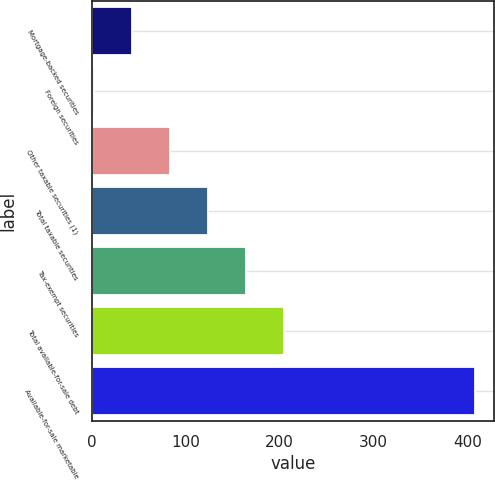Convert chart to OTSL. <chart><loc_0><loc_0><loc_500><loc_500><bar_chart><fcel>Mortgage-backed securities<fcel>Foreign securities<fcel>Other taxable securities (1)<fcel>Total taxable securities<fcel>Tax-exempt securities<fcel>Total available-for-sale debt<fcel>Available-for-sale marketable<nl><fcel>42.6<fcel>2<fcel>83.2<fcel>123.8<fcel>164.4<fcel>205<fcel>408<nl></chart> 